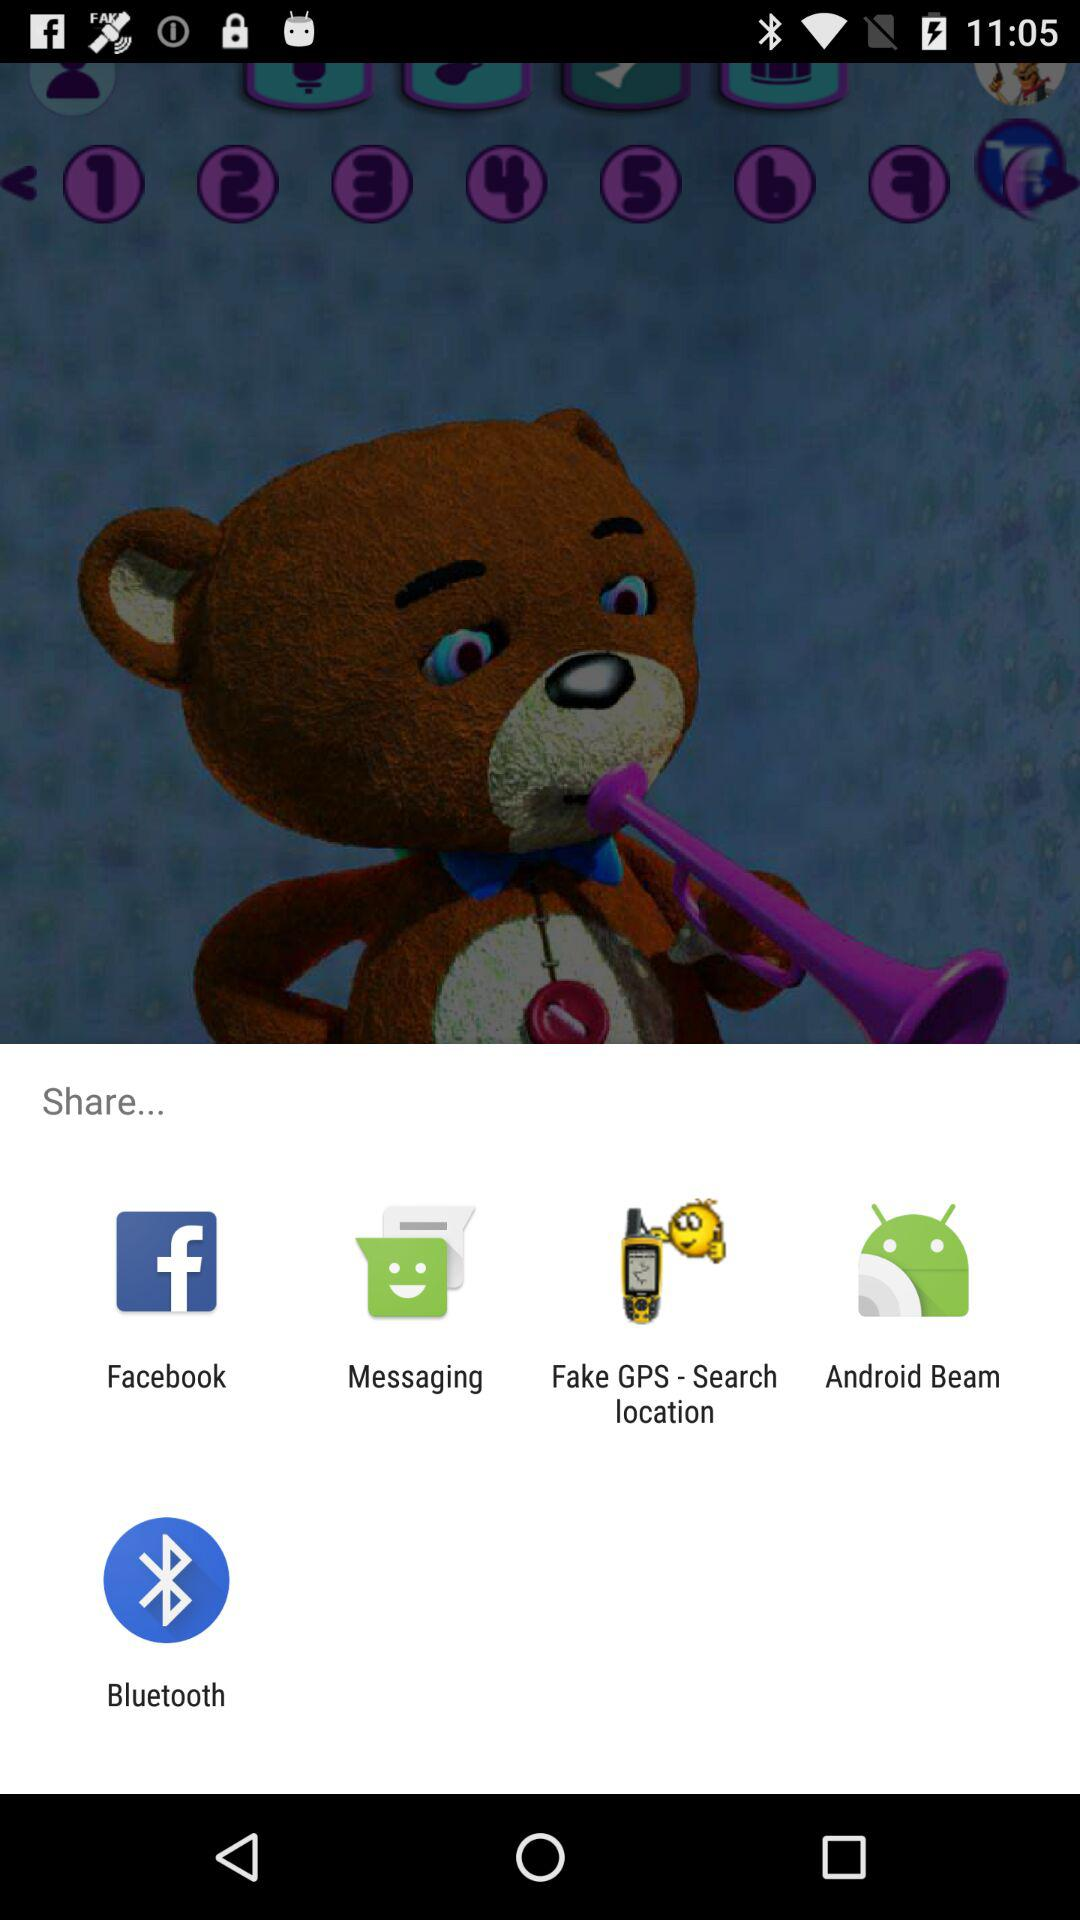Who is sharing this content?
When the provided information is insufficient, respond with <no answer>. <no answer> 